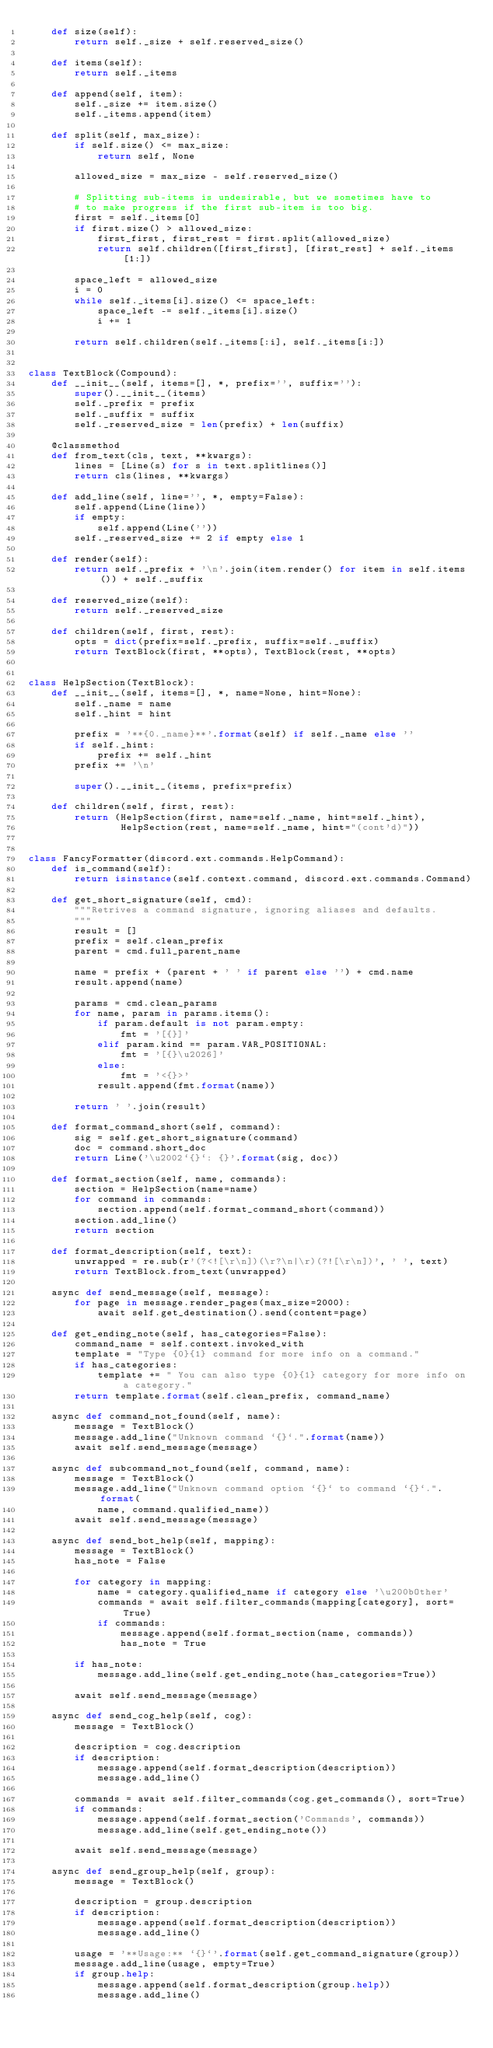Convert code to text. <code><loc_0><loc_0><loc_500><loc_500><_Python_>    def size(self):
        return self._size + self.reserved_size()

    def items(self):
        return self._items

    def append(self, item):
        self._size += item.size()
        self._items.append(item)

    def split(self, max_size):
        if self.size() <= max_size:
            return self, None

        allowed_size = max_size - self.reserved_size()

        # Splitting sub-items is undesirable, but we sometimes have to
        # to make progress if the first sub-item is too big.
        first = self._items[0]
        if first.size() > allowed_size:
            first_first, first_rest = first.split(allowed_size)
            return self.children([first_first], [first_rest] + self._items[1:])

        space_left = allowed_size
        i = 0
        while self._items[i].size() <= space_left:
            space_left -= self._items[i].size()
            i += 1

        return self.children(self._items[:i], self._items[i:])


class TextBlock(Compound):
    def __init__(self, items=[], *, prefix='', suffix=''):
        super().__init__(items)
        self._prefix = prefix
        self._suffix = suffix
        self._reserved_size = len(prefix) + len(suffix)

    @classmethod
    def from_text(cls, text, **kwargs):
        lines = [Line(s) for s in text.splitlines()]
        return cls(lines, **kwargs)

    def add_line(self, line='', *, empty=False):
        self.append(Line(line))
        if empty:
            self.append(Line(''))
        self._reserved_size += 2 if empty else 1

    def render(self):
        return self._prefix + '\n'.join(item.render() for item in self.items()) + self._suffix

    def reserved_size(self):
        return self._reserved_size

    def children(self, first, rest):
        opts = dict(prefix=self._prefix, suffix=self._suffix)
        return TextBlock(first, **opts), TextBlock(rest, **opts)


class HelpSection(TextBlock):
    def __init__(self, items=[], *, name=None, hint=None):
        self._name = name
        self._hint = hint

        prefix = '**{0._name}**'.format(self) if self._name else ''
        if self._hint:
            prefix += self._hint
        prefix += '\n'

        super().__init__(items, prefix=prefix)

    def children(self, first, rest):
        return (HelpSection(first, name=self._name, hint=self._hint),
                HelpSection(rest, name=self._name, hint="(cont'd)"))


class FancyFormatter(discord.ext.commands.HelpCommand):
    def is_command(self):
        return isinstance(self.context.command, discord.ext.commands.Command)

    def get_short_signature(self, cmd):
        """Retrives a command signature, ignoring aliases and defaults.
        """
        result = []
        prefix = self.clean_prefix
        parent = cmd.full_parent_name

        name = prefix + (parent + ' ' if parent else '') + cmd.name
        result.append(name)

        params = cmd.clean_params
        for name, param in params.items():
            if param.default is not param.empty:
                fmt = '[{}]'
            elif param.kind == param.VAR_POSITIONAL:
                fmt = '[{}\u2026]'
            else:
                fmt = '<{}>'
            result.append(fmt.format(name))

        return ' '.join(result)

    def format_command_short(self, command):
        sig = self.get_short_signature(command)
        doc = command.short_doc
        return Line('\u2002`{}`: {}'.format(sig, doc))

    def format_section(self, name, commands):
        section = HelpSection(name=name)
        for command in commands:
            section.append(self.format_command_short(command))
        section.add_line()
        return section

    def format_description(self, text):
        unwrapped = re.sub(r'(?<![\r\n])(\r?\n|\r)(?![\r\n])', ' ', text)
        return TextBlock.from_text(unwrapped)

    async def send_message(self, message):
        for page in message.render_pages(max_size=2000):
            await self.get_destination().send(content=page)

    def get_ending_note(self, has_categories=False):
        command_name = self.context.invoked_with
        template = "Type {0}{1} command for more info on a command."
        if has_categories:
            template += " You can also type {0}{1} category for more info on a category."
        return template.format(self.clean_prefix, command_name)

    async def command_not_found(self, name):
        message = TextBlock()
        message.add_line("Unknown command `{}`.".format(name))
        await self.send_message(message)

    async def subcommand_not_found(self, command, name):
        message = TextBlock()
        message.add_line("Unknown command option `{}` to command `{}`.".format(
            name, command.qualified_name))
        await self.send_message(message)

    async def send_bot_help(self, mapping):
        message = TextBlock()
        has_note = False

        for category in mapping:
            name = category.qualified_name if category else '\u200bOther'
            commands = await self.filter_commands(mapping[category], sort=True)
            if commands:
                message.append(self.format_section(name, commands))
                has_note = True

        if has_note:
            message.add_line(self.get_ending_note(has_categories=True))

        await self.send_message(message)

    async def send_cog_help(self, cog):
        message = TextBlock()

        description = cog.description
        if description:
            message.append(self.format_description(description))
            message.add_line()

        commands = await self.filter_commands(cog.get_commands(), sort=True)
        if commands:
            message.append(self.format_section('Commands', commands))
            message.add_line(self.get_ending_note())

        await self.send_message(message)

    async def send_group_help(self, group):
        message = TextBlock()

        description = group.description
        if description:
            message.append(self.format_description(description))
            message.add_line()

        usage = '**Usage:** `{}`'.format(self.get_command_signature(group))
        message.add_line(usage, empty=True)
        if group.help:
            message.append(self.format_description(group.help))
            message.add_line()
</code> 